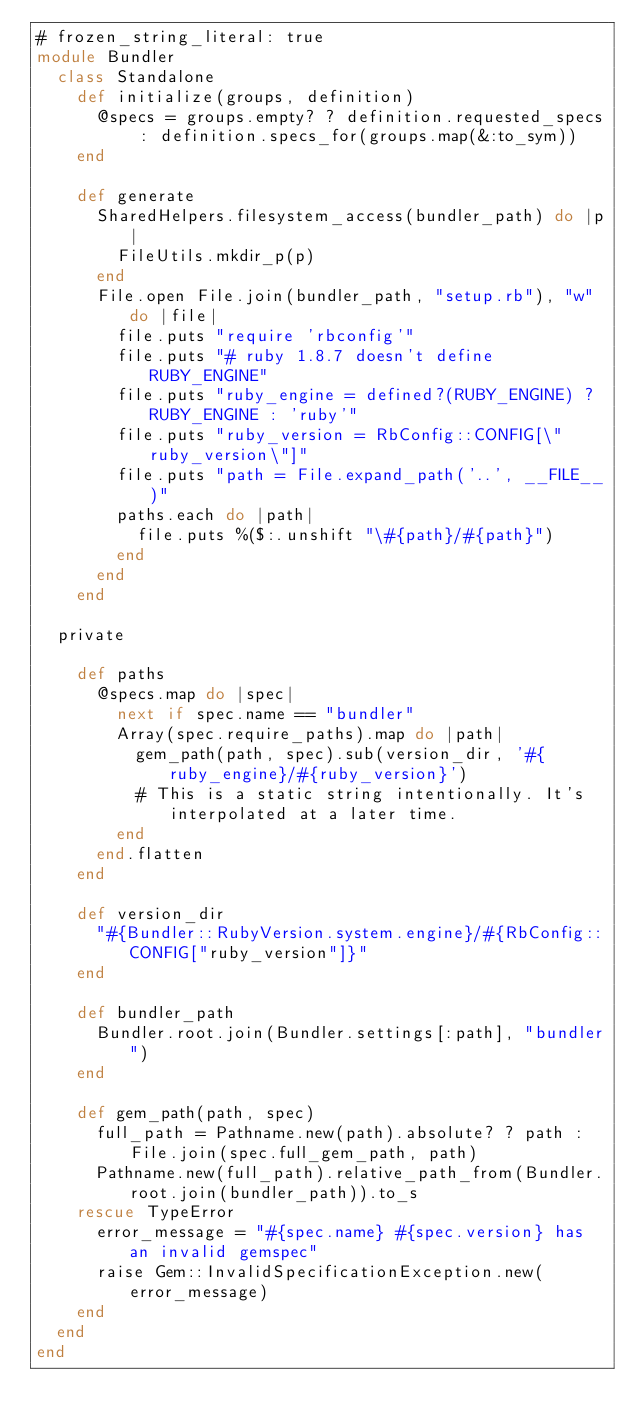<code> <loc_0><loc_0><loc_500><loc_500><_Ruby_># frozen_string_literal: true
module Bundler
  class Standalone
    def initialize(groups, definition)
      @specs = groups.empty? ? definition.requested_specs : definition.specs_for(groups.map(&:to_sym))
    end

    def generate
      SharedHelpers.filesystem_access(bundler_path) do |p|
        FileUtils.mkdir_p(p)
      end
      File.open File.join(bundler_path, "setup.rb"), "w" do |file|
        file.puts "require 'rbconfig'"
        file.puts "# ruby 1.8.7 doesn't define RUBY_ENGINE"
        file.puts "ruby_engine = defined?(RUBY_ENGINE) ? RUBY_ENGINE : 'ruby'"
        file.puts "ruby_version = RbConfig::CONFIG[\"ruby_version\"]"
        file.puts "path = File.expand_path('..', __FILE__)"
        paths.each do |path|
          file.puts %($:.unshift "\#{path}/#{path}")
        end
      end
    end

  private

    def paths
      @specs.map do |spec|
        next if spec.name == "bundler"
        Array(spec.require_paths).map do |path|
          gem_path(path, spec).sub(version_dir, '#{ruby_engine}/#{ruby_version}')
          # This is a static string intentionally. It's interpolated at a later time.
        end
      end.flatten
    end

    def version_dir
      "#{Bundler::RubyVersion.system.engine}/#{RbConfig::CONFIG["ruby_version"]}"
    end

    def bundler_path
      Bundler.root.join(Bundler.settings[:path], "bundler")
    end

    def gem_path(path, spec)
      full_path = Pathname.new(path).absolute? ? path : File.join(spec.full_gem_path, path)
      Pathname.new(full_path).relative_path_from(Bundler.root.join(bundler_path)).to_s
    rescue TypeError
      error_message = "#{spec.name} #{spec.version} has an invalid gemspec"
      raise Gem::InvalidSpecificationException.new(error_message)
    end
  end
end
</code> 